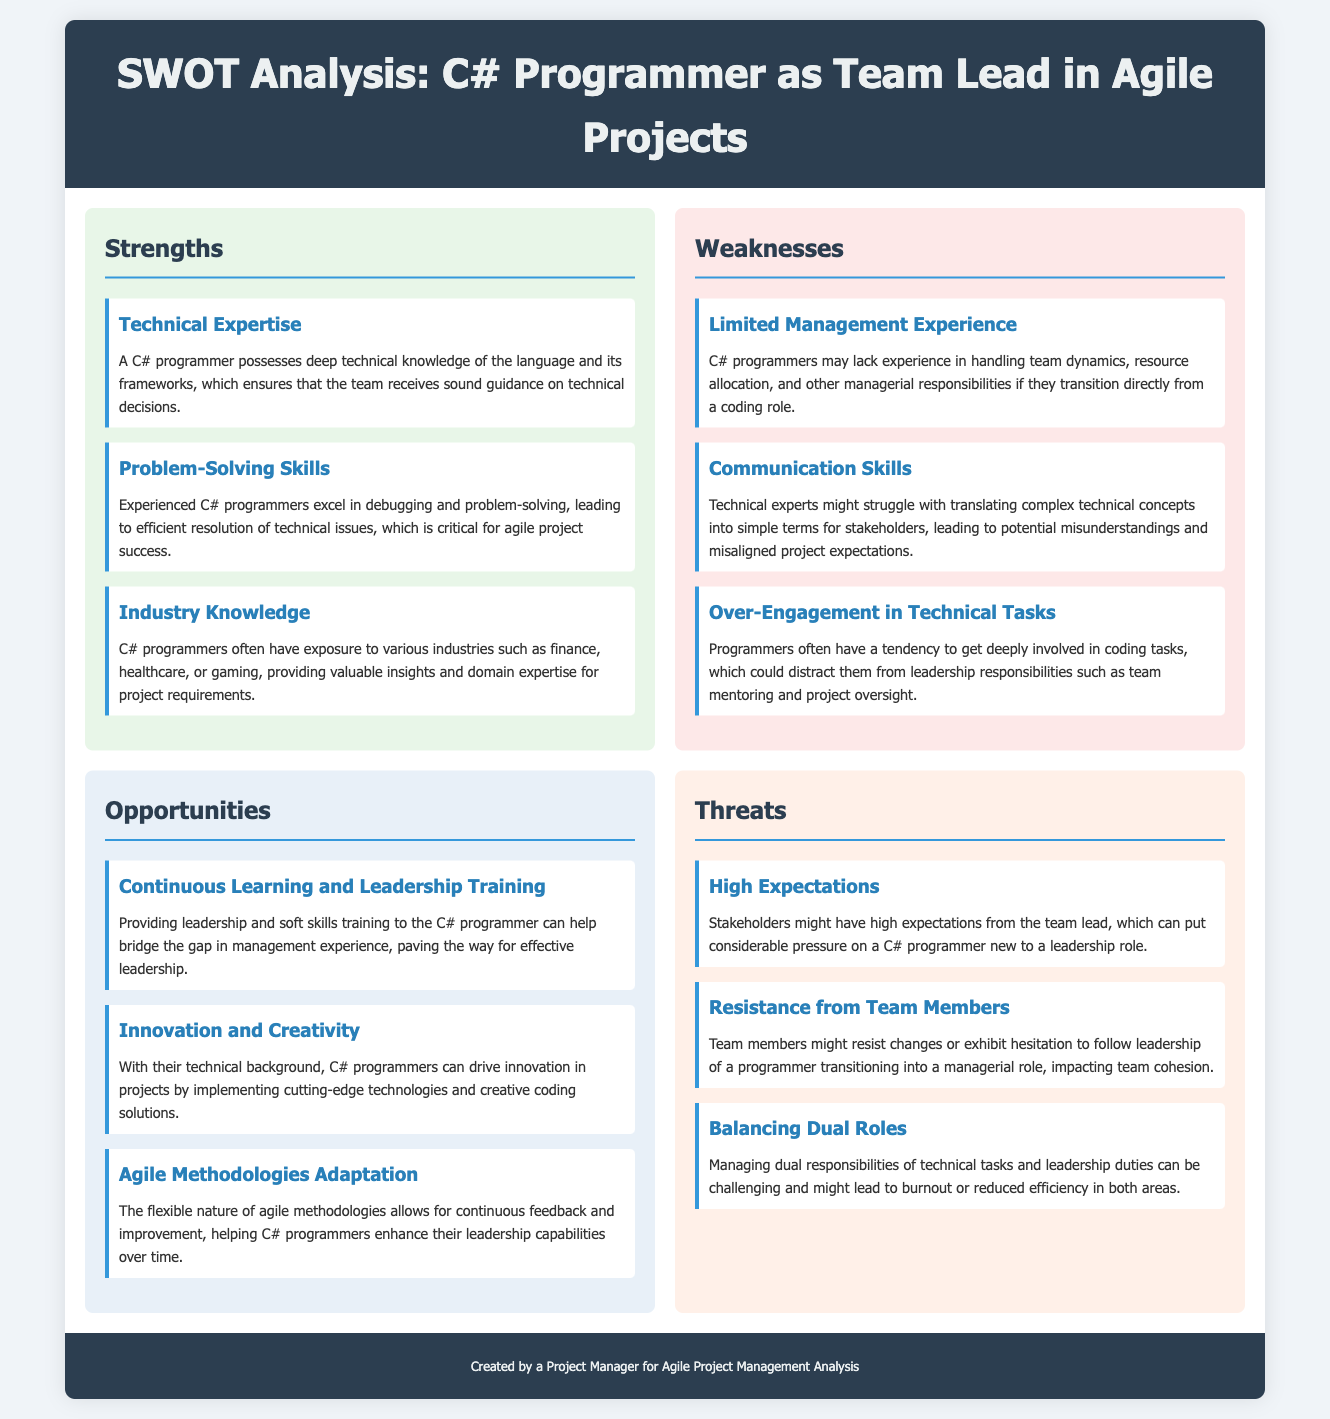What is the title of the SWOT analysis? The title is located in the header of the document.
Answer: SWOT Analysis: C# Programmer as Team Lead in Agile Projects How many strengths are listed in the analysis? The strengths are listed under the Strengths section, where three items are mentioned.
Answer: 3 What is one strength mentioned about C# programmers? The strengths section includes several points, one of which is highlighted.
Answer: Technical Expertise What kind of training is suggested for C# programmers? The Opportunities section recommends specific training for C# programmers.
Answer: Leadership and soft skills training What is the first weakness identified in the analysis? The first item listed under the Weaknesses section provides this information.
Answer: Limited Management Experience What can high expectations from stakeholders lead to? This is mentioned in the Threats section regarding the effect of high expectations.
Answer: Pressure on a C# programmer How many opportunities are identified in the analysis? The Opportunities section lists specific opportunities available.
Answer: 3 What is one threat associated with balancing dual roles? The Threats section describes the effects of balancing responsibilities.
Answer: Burnout What industry knowledge is typically provided by C# programmers? One item in the Strengths section mentions this aspect.
Answer: Exposure to various industries 